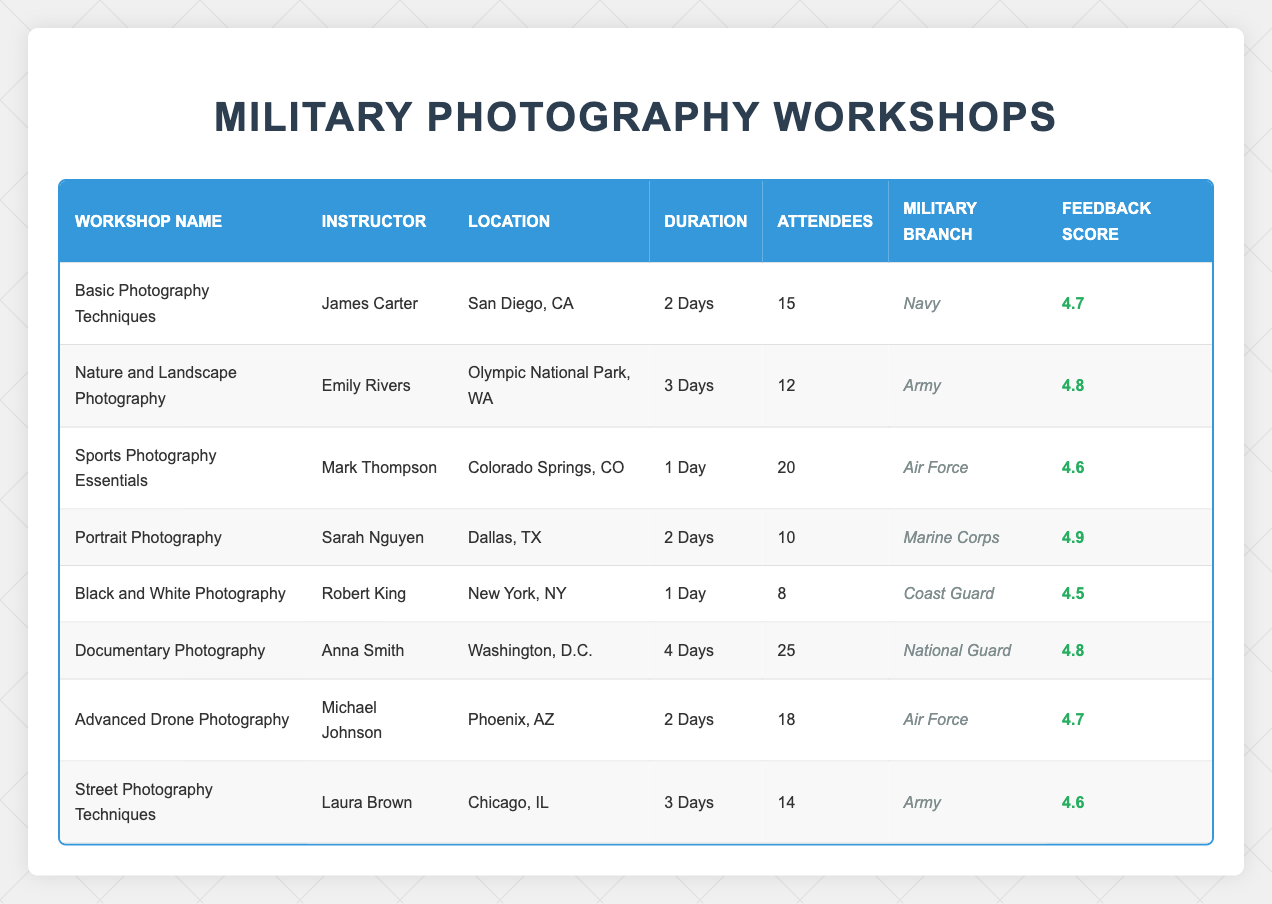What is the total number of attendees in all workshops? To find the total number of attendees, sum the attendees from each workshop: 15 + 12 + 20 + 10 + 8 + 25 + 18 + 14 = 132.
Answer: 132 Which workshop had the highest feedback score? The feedback scores are 4.7, 4.8, 4.6, 4.9, 4.5, 4.8, 4.7, and 4.6. The highest score is 4.9, corresponding to the "Portrait Photography" workshop.
Answer: Portrait Photography How many workshops were conducted in Texas? The table lists workshops in San Diego, Olympic National Park, Colorado Springs, Dallas, New York, Washington D.C., Phoenix, and Chicago. Only the "Portrait Photography" workshop is in Texas (Dallas).
Answer: 1 What is the average feedback score of all workshops? Add all the feedback scores: 4.7 + 4.8 + 4.6 + 4.9 + 4.5 + 4.8 + 4.7 + 4.6 = 37.6. There are 8 workshops, so divide 37.6 by 8 to get the average: 37.6 / 8 = 4.7.
Answer: 4.7 Is there any workshop with more than 20 attendees? The "Documentary Photography" workshop has 25 attendees, which is more than 20.
Answer: Yes Which military branch had the most attendees across all workshops? Count the attendees by military branch: Navy (15), Army (12 + 14 = 26), Air Force (20 + 18 = 38), Marine Corps (10), Coast Guard (8), National Guard (25). The Air Force has the highest total with 38 attendees.
Answer: Air Force What is the duration of the "Advanced Drone Photography" workshop? The table indicates that the "Advanced Drone Photography" workshop has a duration of 2 Days.
Answer: 2 Days How many different military branches participated in the workshops? The military branches represented are Navy, Army, Air Force, Marine Corps, Coast Guard, and National Guard. There are 6 different branches listed.
Answer: 6 What is the difference in feedback score between the workshop with the highest and the lowest score? The highest score is 4.9 (Portrait Photography) and the lowest is 4.5 (Black and White Photography). The difference is 4.9 - 4.5 = 0.4.
Answer: 0.4 How many workshops were conducted in locations outside of the state of California? Only the "Basic Photography Techniques" workshop is located in California. Thus, there are 7 workshops in other states: WA, CO, TX, NY, D.C., AZ, and IL.
Answer: 7 